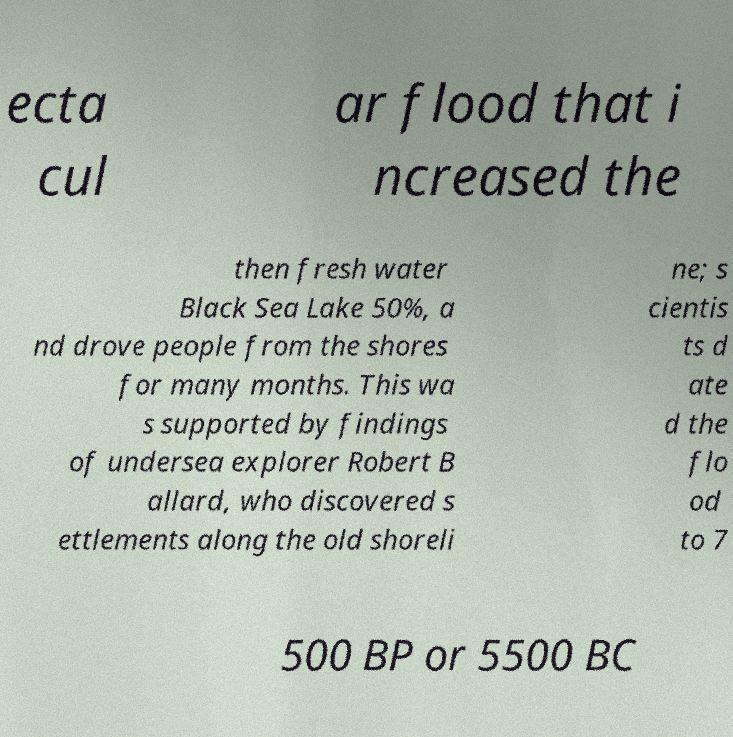Can you read and provide the text displayed in the image?This photo seems to have some interesting text. Can you extract and type it out for me? ecta cul ar flood that i ncreased the then fresh water Black Sea Lake 50%, a nd drove people from the shores for many months. This wa s supported by findings of undersea explorer Robert B allard, who discovered s ettlements along the old shoreli ne; s cientis ts d ate d the flo od to 7 500 BP or 5500 BC 